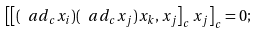<formula> <loc_0><loc_0><loc_500><loc_500>\left [ \left [ ( \ a d _ { c } x _ { i } ) ( \ a d _ { c } x _ { j } ) x _ { k } , x _ { j } \right ] _ { c } x _ { j } \right ] _ { c } = 0 ;</formula> 